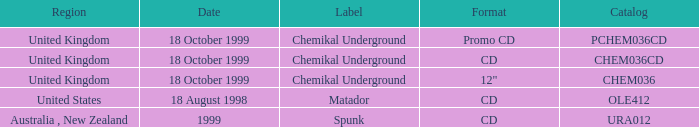What title holds an inventory of chem036cd? Chemikal Underground. Write the full table. {'header': ['Region', 'Date', 'Label', 'Format', 'Catalog'], 'rows': [['United Kingdom', '18 October 1999', 'Chemikal Underground', 'Promo CD', 'PCHEM036CD'], ['United Kingdom', '18 October 1999', 'Chemikal Underground', 'CD', 'CHEM036CD'], ['United Kingdom', '18 October 1999', 'Chemikal Underground', '12"', 'CHEM036'], ['United States', '18 August 1998', 'Matador', 'CD', 'OLE412'], ['Australia , New Zealand', '1999', 'Spunk', 'CD', 'URA012']]} 